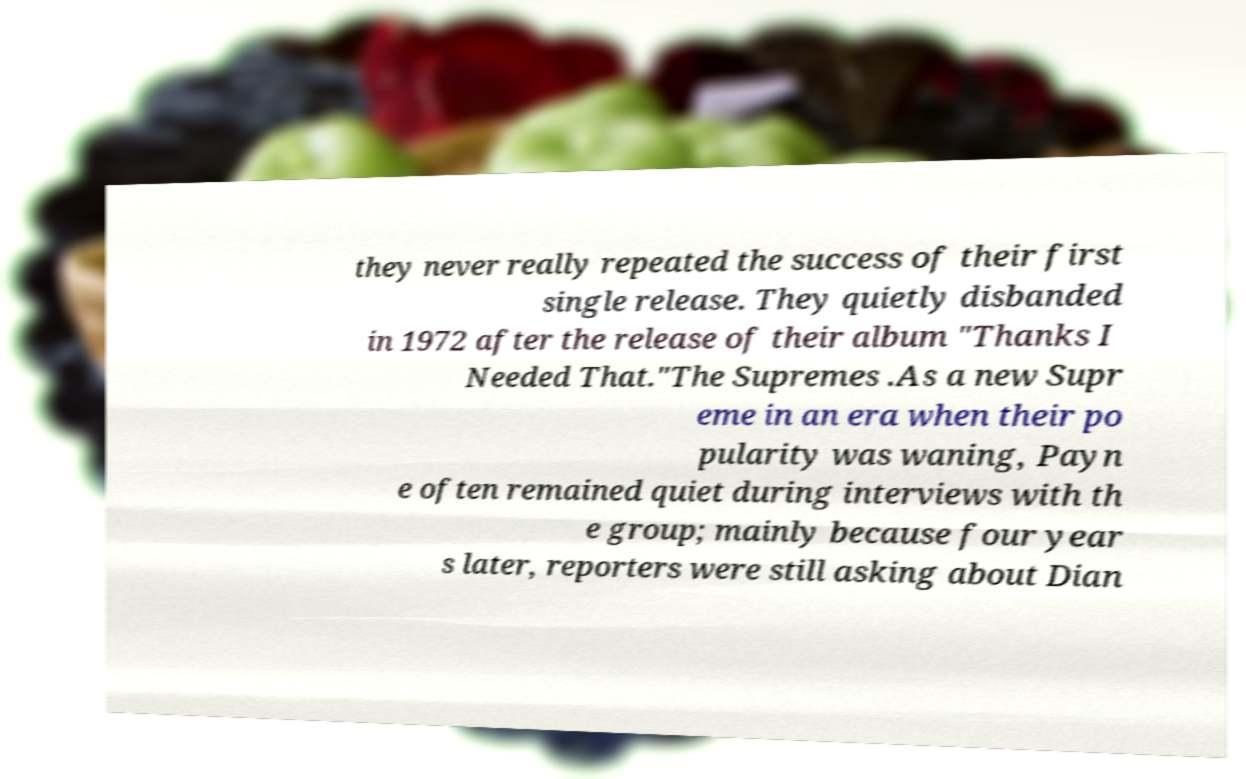Please read and relay the text visible in this image. What does it say? they never really repeated the success of their first single release. They quietly disbanded in 1972 after the release of their album "Thanks I Needed That."The Supremes .As a new Supr eme in an era when their po pularity was waning, Payn e often remained quiet during interviews with th e group; mainly because four year s later, reporters were still asking about Dian 